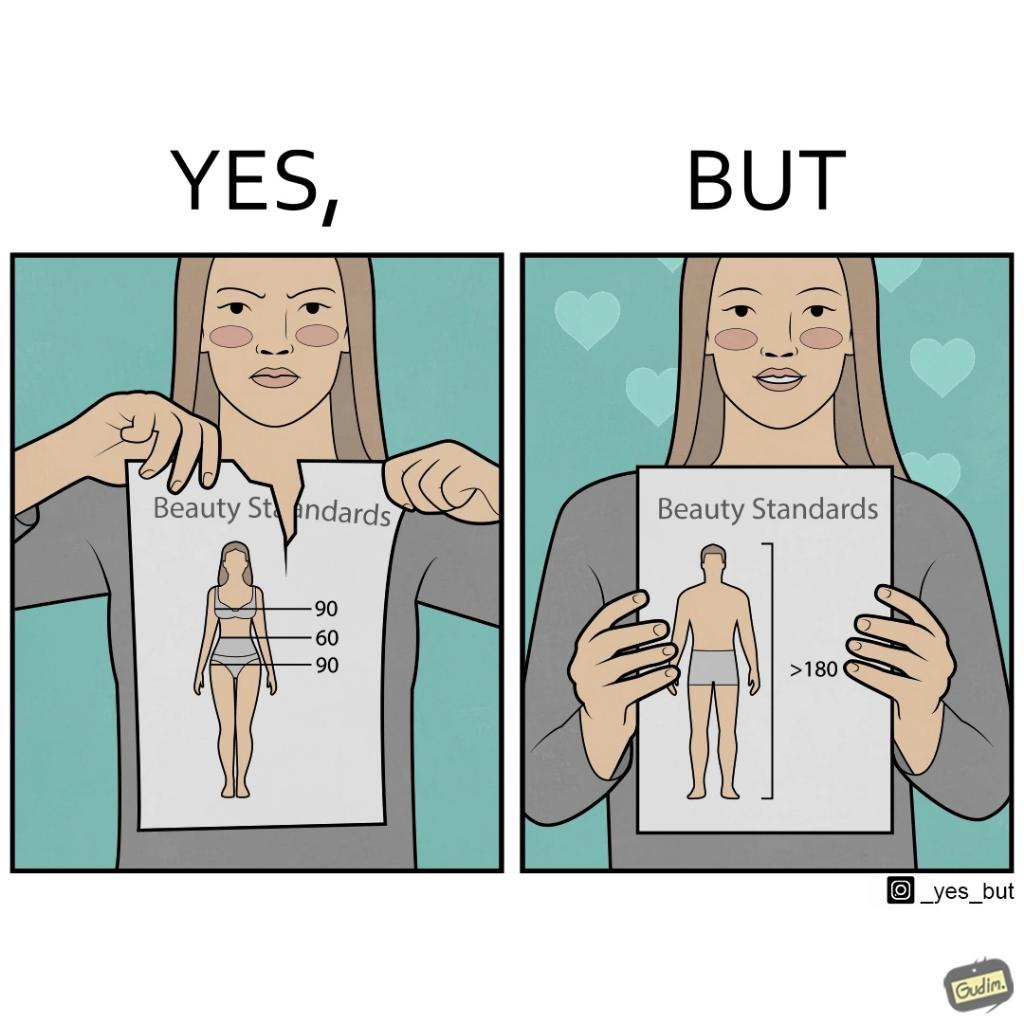Is there satirical content in this image? Yes, this image is satirical. 